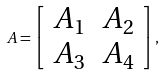<formula> <loc_0><loc_0><loc_500><loc_500>A = \left [ \begin{array} { l l } A _ { 1 } & A _ { 2 } \\ A _ { 3 } & A _ { 4 } \end{array} \right ] ,</formula> 